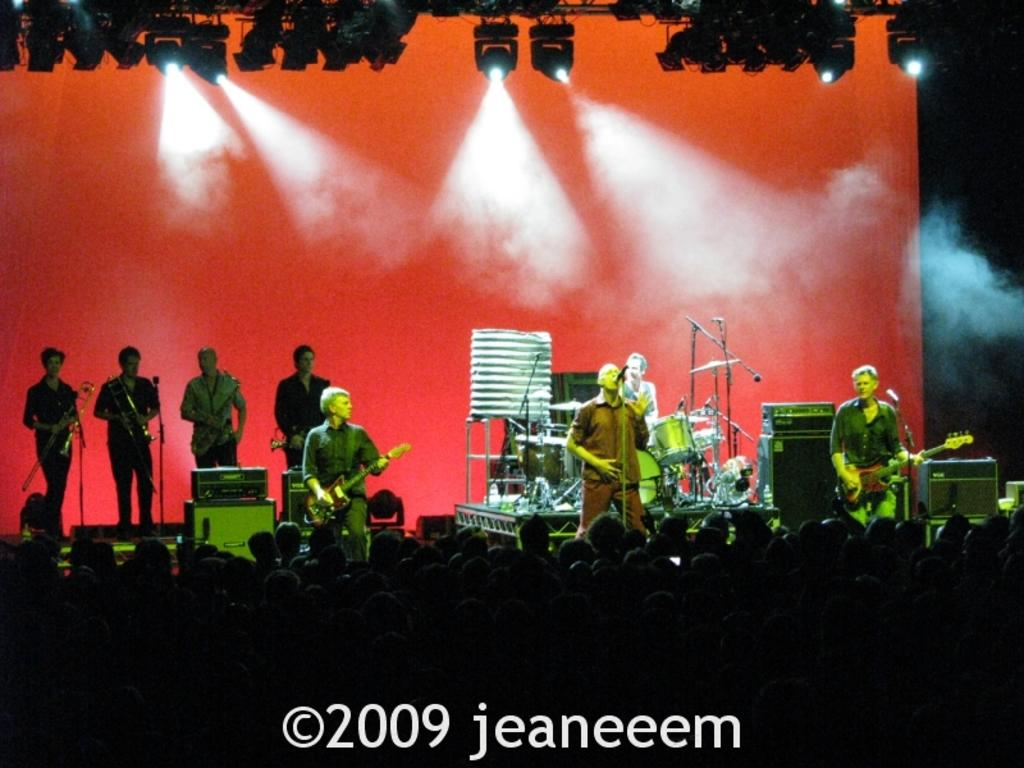What is happening in the center of the image? There are people performing on the stage in the center of the image. What can be seen at the bottom of the image? There are people standing at the bottom of the image. What is visible in the background of the image? There is a wall in the background of the image. Can you see any wild berries growing on the wall in the background? There are no berries, wild or otherwise, visible on the wall in the background of the image. Is there a monkey performing on the stage with the people? There is no monkey present in the image; only people are performing on the stage. 